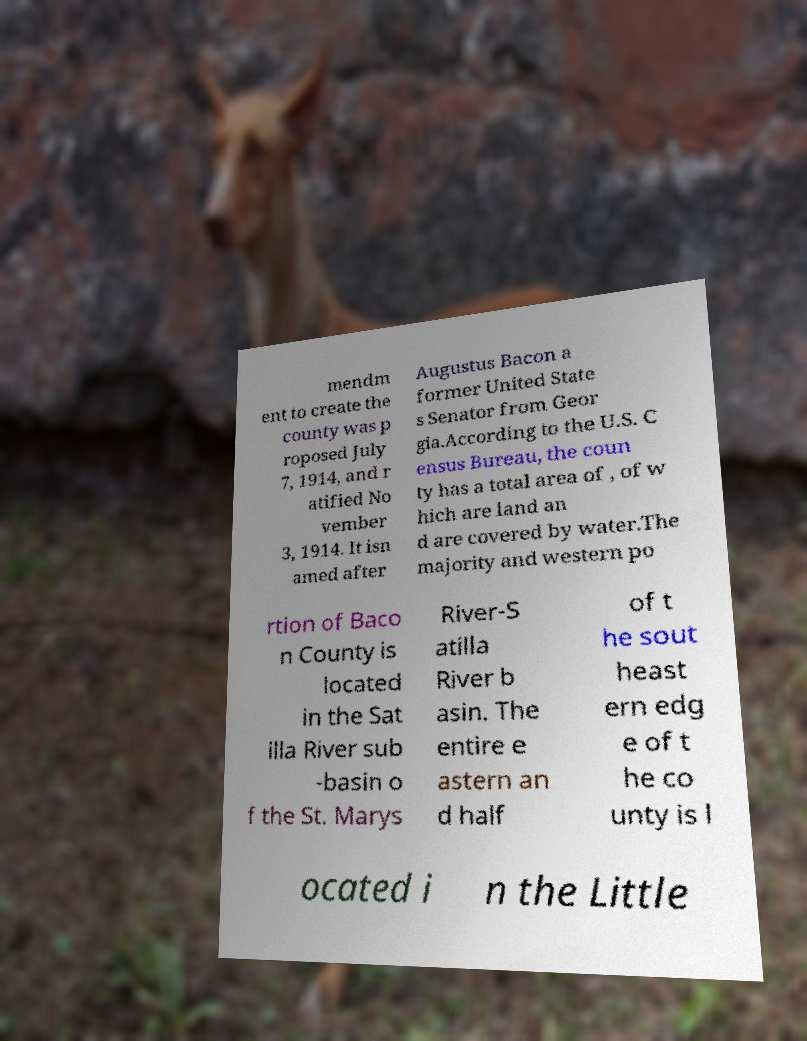What messages or text are displayed in this image? I need them in a readable, typed format. mendm ent to create the county was p roposed July 7, 1914, and r atified No vember 3, 1914. It isn amed after Augustus Bacon a former United State s Senator from Geor gia.According to the U.S. C ensus Bureau, the coun ty has a total area of , of w hich are land an d are covered by water.The majority and western po rtion of Baco n County is located in the Sat illa River sub -basin o f the St. Marys River-S atilla River b asin. The entire e astern an d half of t he sout heast ern edg e of t he co unty is l ocated i n the Little 